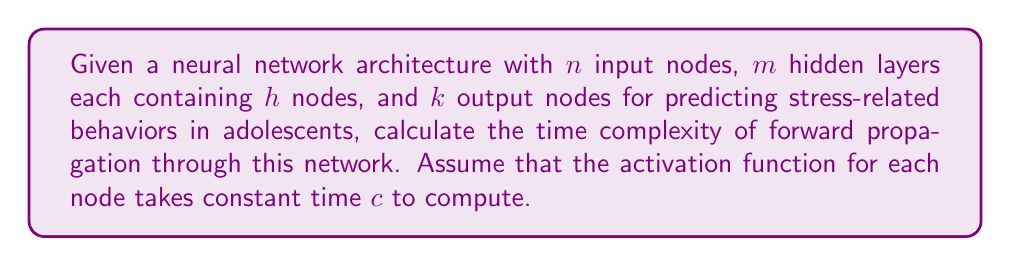Provide a solution to this math problem. To calculate the time complexity of forward propagation through the given neural network architecture, we need to consider the number of computations performed at each layer:

1. Input layer to first hidden layer:
   - Each of the $h$ nodes in the first hidden layer receives input from all $n$ input nodes.
   - Time complexity: $O(n \cdot h)$

2. Hidden layer to hidden layer:
   - There are $m-1$ transitions between hidden layers.
   - Each node in a hidden layer receives input from all $h$ nodes in the previous layer.
   - Time complexity for each transition: $O(h \cdot h)$
   - Total time complexity for hidden layer transitions: $O((m-1) \cdot h \cdot h)$

3. Last hidden layer to output layer:
   - Each of the $k$ output nodes receives input from all $h$ nodes in the last hidden layer.
   - Time complexity: $O(h \cdot k)$

4. Activation function computation:
   - The activation function is applied to each node in the hidden layers and output layer.
   - Total number of nodes where activation is applied: $m \cdot h + k$
   - Time complexity for activation: $O((m \cdot h + k) \cdot c)$

To get the total time complexity, we sum up all the above components:

$$O(n \cdot h + (m-1) \cdot h \cdot h + h \cdot k + (m \cdot h + k) \cdot c)$$

Simplifying and considering the dominant terms:

$$O(n \cdot h + m \cdot h^2 + h \cdot k)$$

Since $c$ is constant, we can drop it from the big O notation.
Answer: $O(n \cdot h + m \cdot h^2 + h \cdot k)$ 